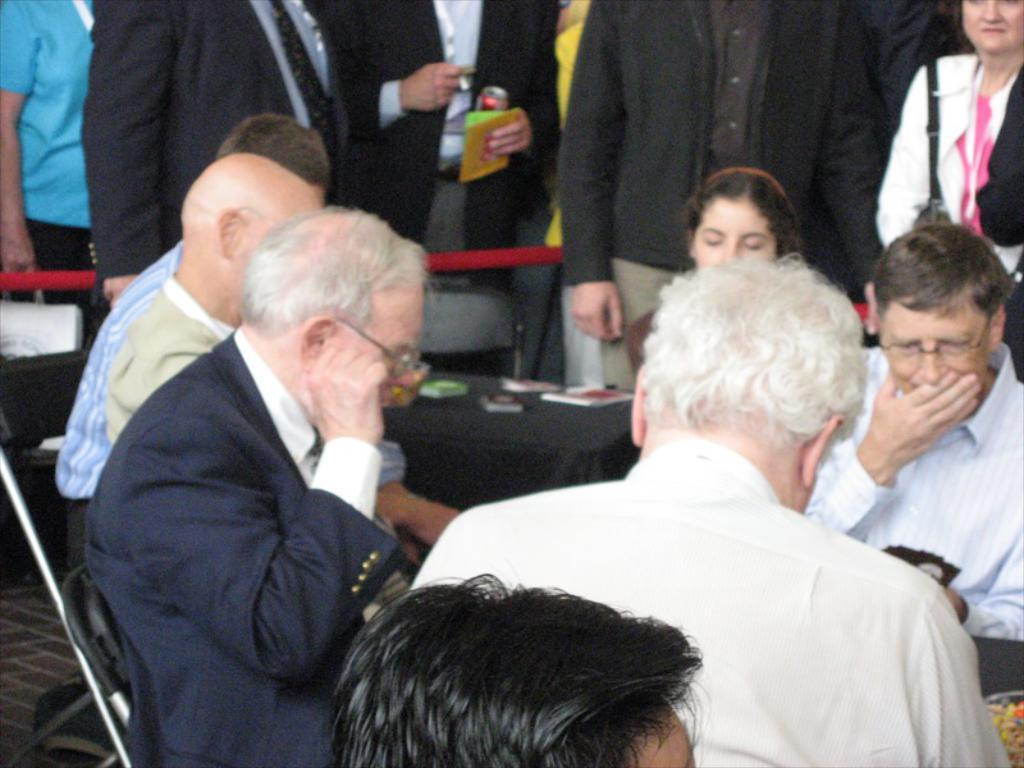What type of furniture is present in the image? There are tables and chairs in the image. What are the people doing while sitting on the chairs? People are sitting on the chairs in the image. What items can be seen on the tables? There are books on the tables in the image. Can you describe the people standing at the top of the image? There are people standing at the top of the image. What type of cattle can be seen grazing near the tables in the image? There are no cattle present in the image; it features tables, chairs, books, and people. How many boats are visible in the image? There are no boats present in the image. 